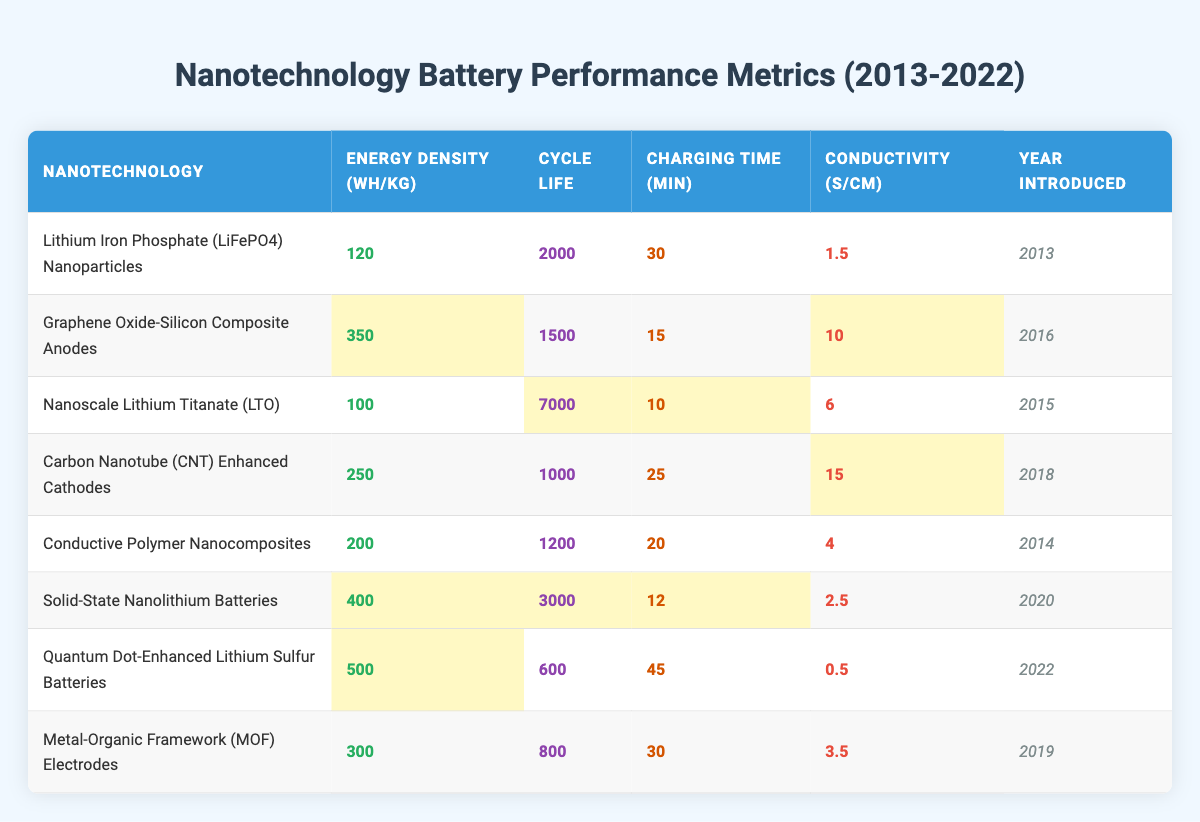What is the highest energy density among the nanotechnologies listed? To find the highest energy density, we look at the "Energy Density (Wh/kg)" column. The maximum value is 500, which corresponds to the "Quantum Dot-Enhanced Lithium Sulfur Batteries."
Answer: 500 What is the cycle life of Nanoscale Lithium Titanate (LTO)? Referring to the row for "Nanoscale Lithium Titanate (LTO)," the "Cycle Life" column shows a value of 7000.
Answer: 7000 Which nanotechnology has the shortest charging time? The charging times can be found in the "Charging Time (min)" column. By comparing the values, "Nanoscale Lithium Titanate (LTO)" has the shortest charging time at 10 minutes.
Answer: 10 minutes Is the conductivity of Graphene Oxide-Silicon Composite Anodes greater than that of Conductive Polymer Nanocomposites? The conductivity of Graphene Oxide-Silicon Composite Anodes is 10, while that of Conductive Polymer Nanocomposites is 4; therefore, Graphene Oxide-Silicon Composite Anodes has higher conductivity.
Answer: Yes Calculate the average charging time of all the nanotechnologies. Summing the charging times: 30 + 15 + 10 + 25 + 20 + 12 + 45 + 30 =  192. We divide by the number of technologies (8) to find the average: 192 / 8 = 24.
Answer: 24 minutes Which nanotechnology was introduced most recently and what is its energy density? The most recent introduction can be found in the "Year Introduced" column, indicating the latest year is 2022 for "Quantum Dot-Enhanced Lithium Sulfur Batteries," which has an energy density of 500 Wh/kg.
Answer: 500 Wh/kg How does the cycle life of Solid-State Nanolithium Batteries compare to that of Carbon Nanotube (CNT) Enhanced Cathodes? Solid-State Nanolithium Batteries have a cycle life of 3000, while Carbon Nanotube (CNT) Enhanced Cathodes have a cycle life of 1000. Therefore, Solid-State Nanolithium Batteries have a longer cycle life.
Answer: Longer Are there any nanotechnologies with both energy densities above 300 Wh/kg and charging times below 20 minutes? By examining the relevant columns, "Graphene Oxide-Silicon Composite Anodes" (350 Wh/kg, 15 min) and "Solid-State Nanolithium Batteries" (400 Wh/kg, 12 min) meet these criteria, confirming the existence.
Answer: Yes What is the conductivity difference between Quantum Dot-Enhanced Lithium Sulfur Batteries and Nanoscale Lithium Titanate (LTO)? The conductivity for Quantum Dot-Enhanced Lithium Sulfur Batteries is 0.5, while for Nanoscale Lithium Titanate it is 6. The difference is calculated as 6 - 0.5 = 5.5.
Answer: 5.5 S/cm Identify the nanotechnology with the second highest cycle life. The cycle life data shows that "Nanoscale Lithium Titanate (LTO)" has the highest (7000) and "Solid-State Nanolithium Batteries" has the second highest at 3000.
Answer: Solid-State Nanolithium Batteries 